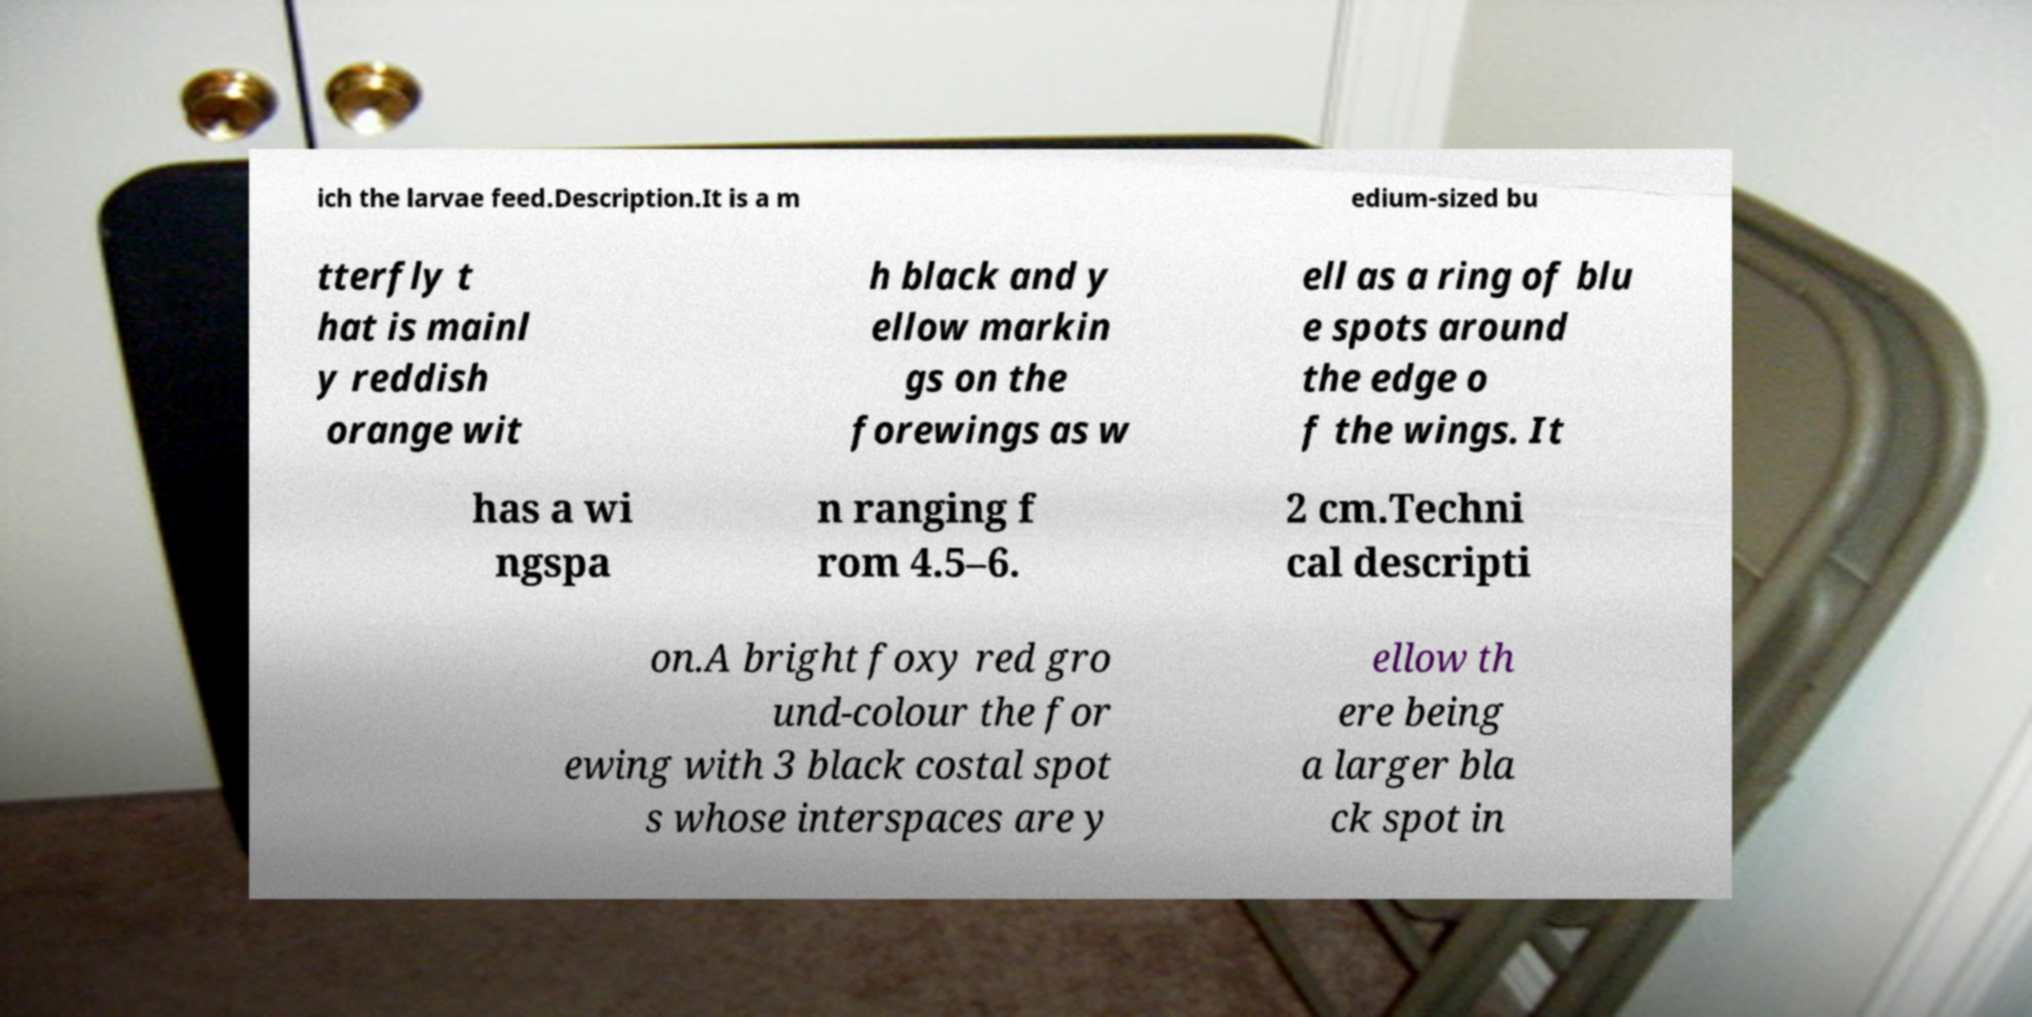For documentation purposes, I need the text within this image transcribed. Could you provide that? ich the larvae feed.Description.It is a m edium-sized bu tterfly t hat is mainl y reddish orange wit h black and y ellow markin gs on the forewings as w ell as a ring of blu e spots around the edge o f the wings. It has a wi ngspa n ranging f rom 4.5–6. 2 cm.Techni cal descripti on.A bright foxy red gro und-colour the for ewing with 3 black costal spot s whose interspaces are y ellow th ere being a larger bla ck spot in 